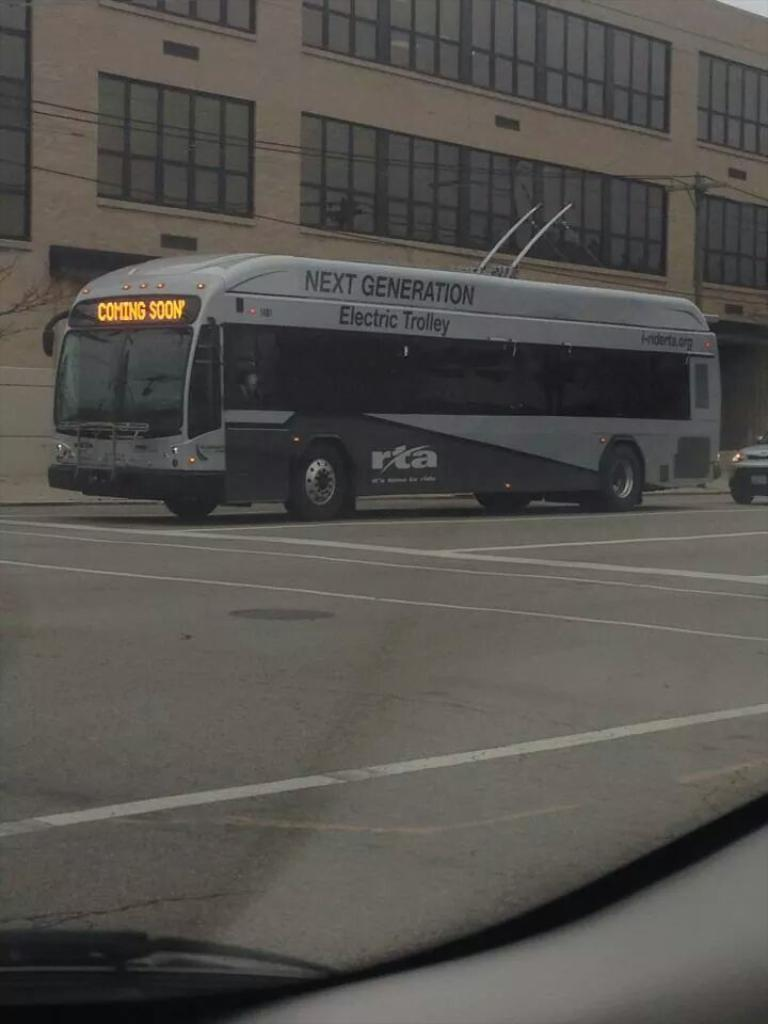What can be seen on the road in the image? There are vehicles on the road in the image. What else is visible in the image besides the vehicles? There are wires and a pole visible in the image. Can you describe the objects in the image? There are some objects in the image, but their specific nature is not clear from the provided facts. What can be seen in the background of the image? There is a building in the background of the image. Is there a crown hanging from the pole in the image? There is no crown present in the image; only vehicles, wires, a pole, and some objects are visible. Can you see a trail of footprints leading to the building in the background? There is no trail of footprints visible in the image; only vehicles, wires, a pole, and some objects are present. 